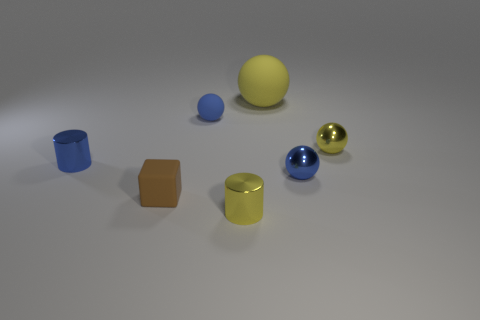What number of red things are either shiny cylinders or tiny metallic blocks?
Provide a short and direct response. 0. What number of large things are the same color as the matte block?
Your answer should be compact. 0. Are the small blue cylinder and the small brown cube made of the same material?
Your answer should be very brief. No. There is a small ball that is on the left side of the big yellow thing; how many brown objects are behind it?
Provide a succinct answer. 0. Does the brown object have the same size as the blue metallic cylinder?
Offer a very short reply. Yes. How many brown things are the same material as the small cube?
Provide a short and direct response. 0. There is a yellow metal thing that is the same shape as the blue matte object; what size is it?
Make the answer very short. Small. There is a tiny metal thing in front of the block; does it have the same shape as the blue matte object?
Ensure brevity in your answer.  No. The blue shiny object that is in front of the blue shiny thing to the left of the big matte thing is what shape?
Provide a succinct answer. Sphere. Is there any other thing that is the same shape as the small blue matte thing?
Your answer should be very brief. Yes. 